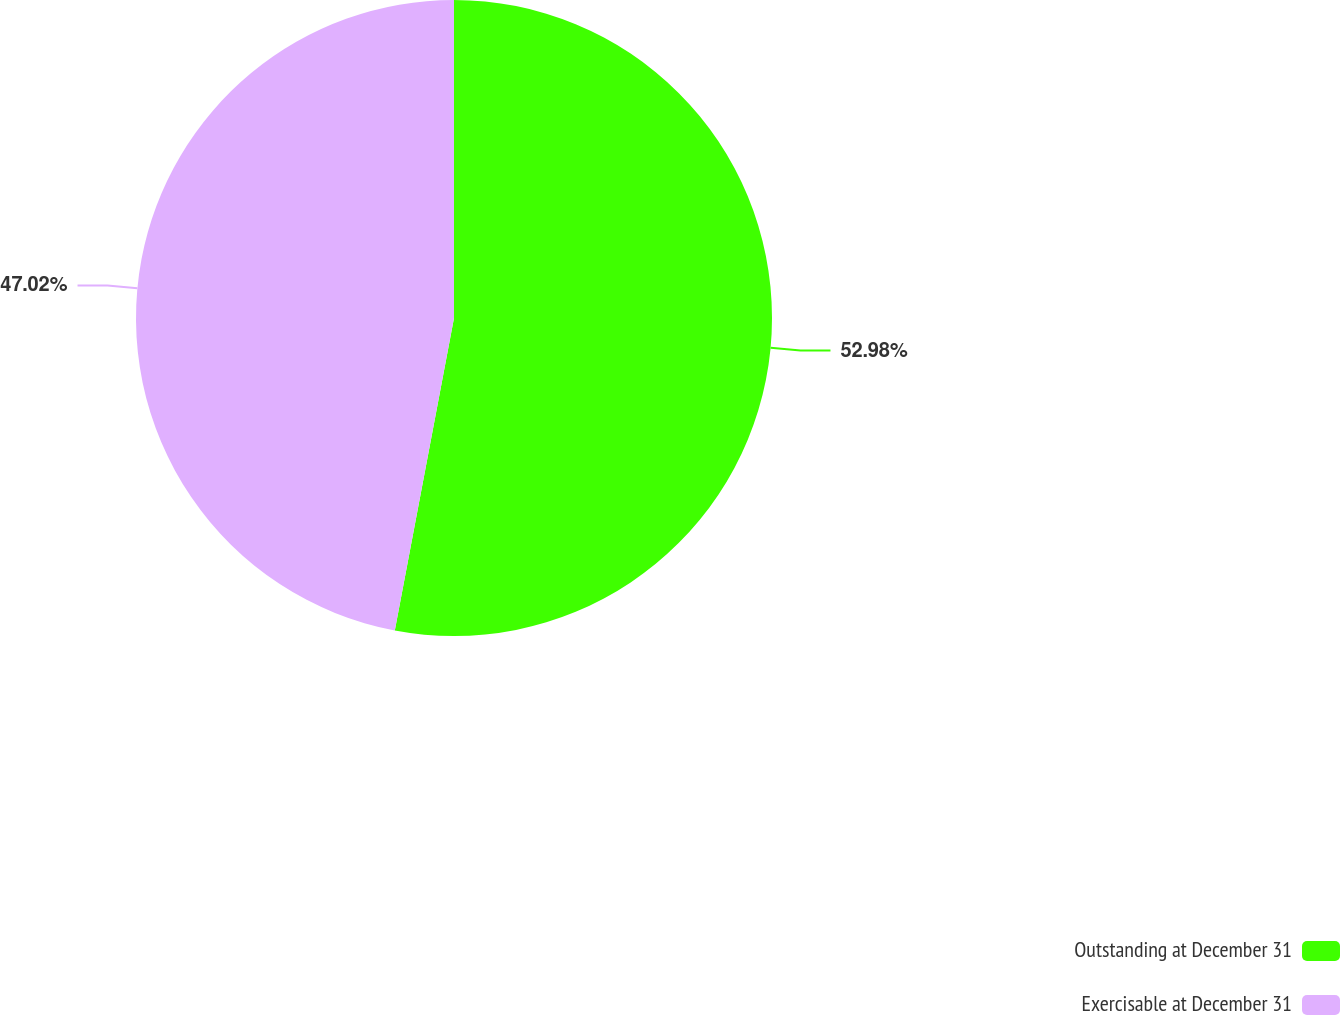<chart> <loc_0><loc_0><loc_500><loc_500><pie_chart><fcel>Outstanding at December 31<fcel>Exercisable at December 31<nl><fcel>52.98%<fcel>47.02%<nl></chart> 